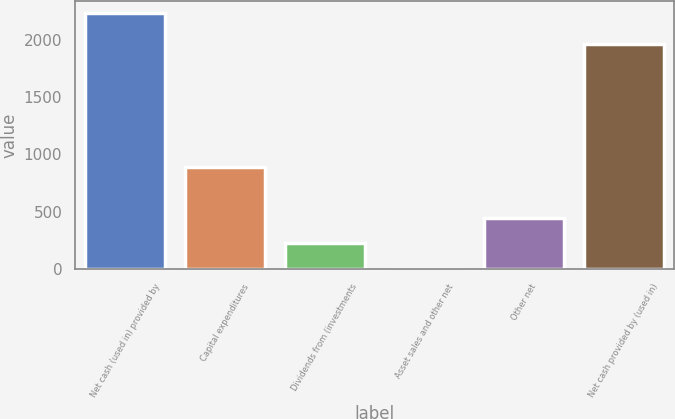Convert chart to OTSL. <chart><loc_0><loc_0><loc_500><loc_500><bar_chart><fcel>Net cash (used in) provided by<fcel>Capital expenditures<fcel>Dividends from (investments<fcel>Asset sales and other net<fcel>Other net<fcel>Net cash provided by (used in)<nl><fcel>2230<fcel>893.2<fcel>224.8<fcel>2<fcel>447.6<fcel>1967<nl></chart> 